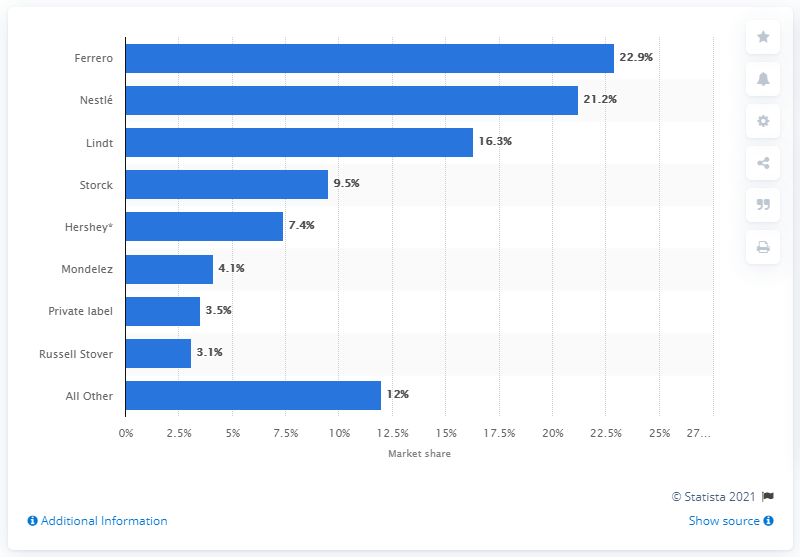Highlight a few significant elements in this photo. In 2018, Nestlé held a market share of 21.2% in boxed chocolate sales. In 2018, Ferrero had the largest market share of Canadian boxed chocolate sales at 22.9 percent. 